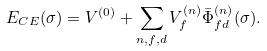Convert formula to latex. <formula><loc_0><loc_0><loc_500><loc_500>E _ { C E } ( \sigma ) = V ^ { ( 0 ) } + \sum _ { n , f , d } V ^ { ( n ) } _ { f } \bar { \Phi } ^ { ( n ) } _ { f d } ( \sigma ) .</formula> 